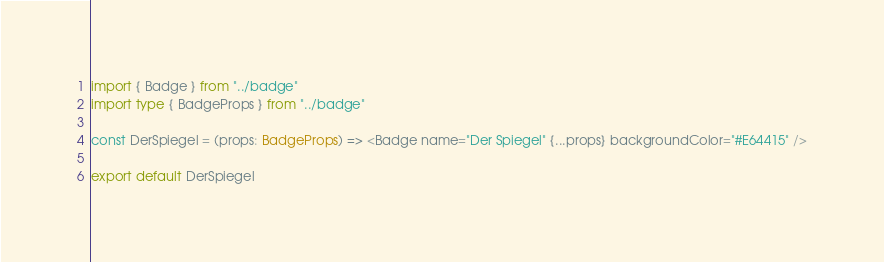Convert code to text. <code><loc_0><loc_0><loc_500><loc_500><_TypeScript_>import { Badge } from "../badge"
import type { BadgeProps } from "../badge"

const DerSpiegel = (props: BadgeProps) => <Badge name="Der Spiegel" {...props} backgroundColor="#E64415" />

export default DerSpiegel
</code> 